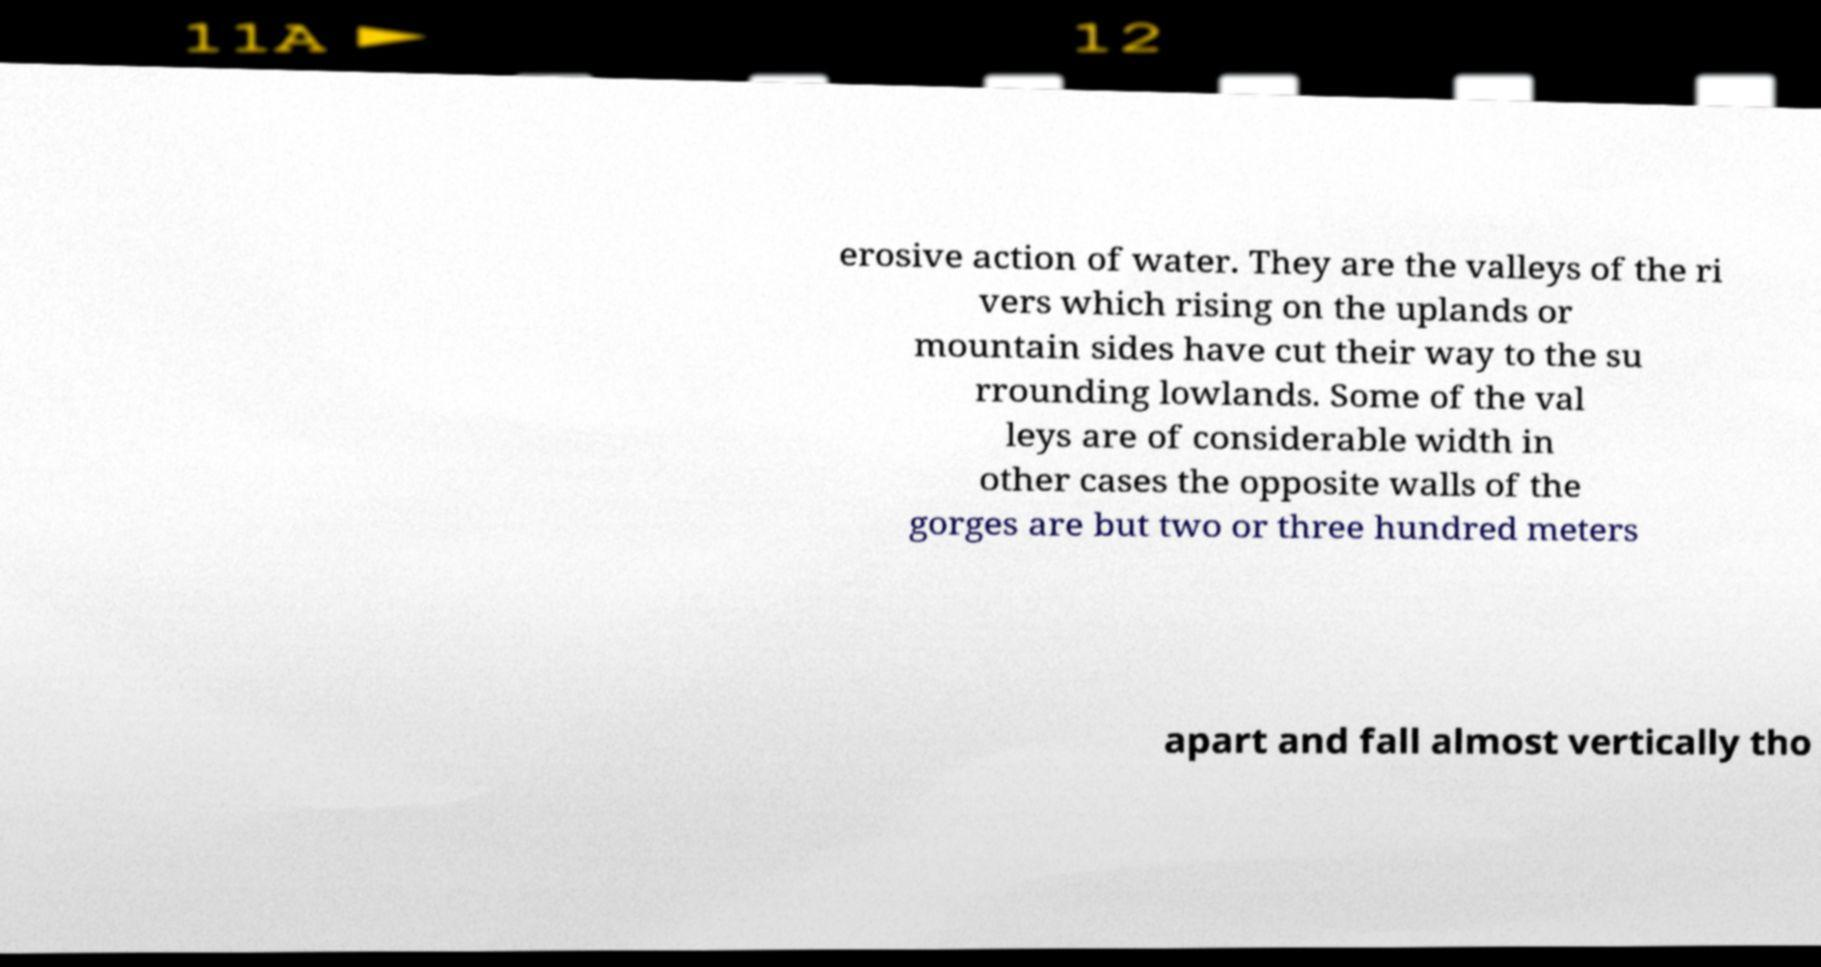Can you accurately transcribe the text from the provided image for me? erosive action of water. They are the valleys of the ri vers which rising on the uplands or mountain sides have cut their way to the su rrounding lowlands. Some of the val leys are of considerable width in other cases the opposite walls of the gorges are but two or three hundred meters apart and fall almost vertically tho 